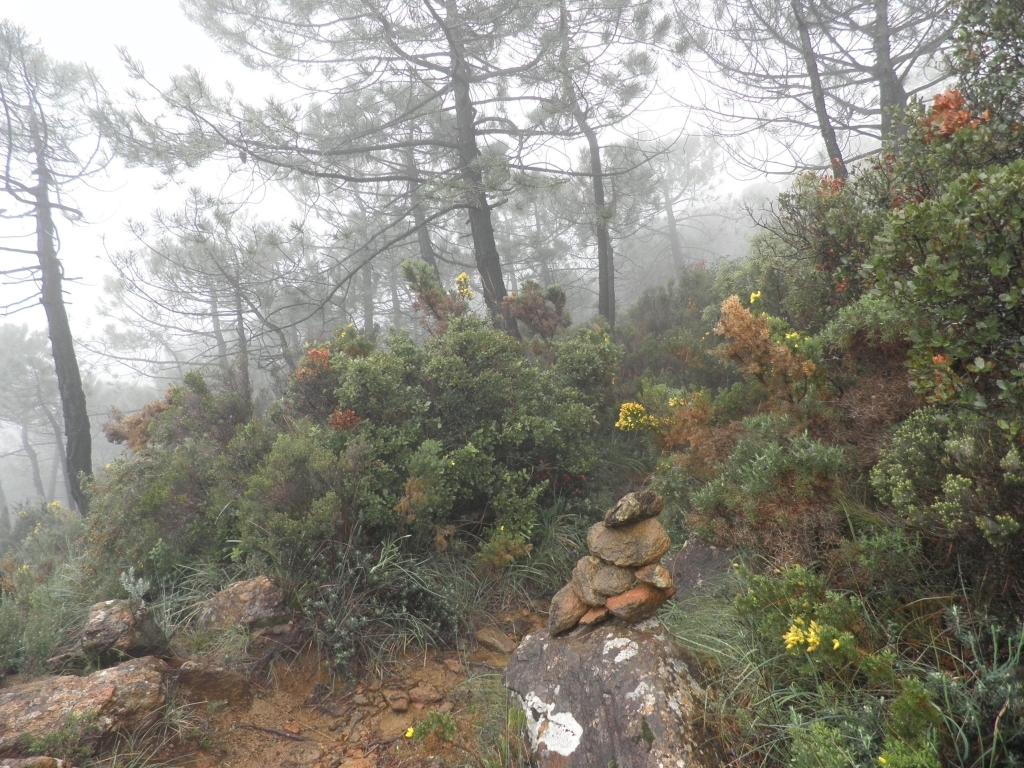What type of natural elements can be seen in the image? There are rocks and plants in the image. What can be seen in the background of the image? There are trees and fog in the background of the image. How many insects can be seen crawling on the rocks in the image? There are no insects visible in the image; it only shows rocks and plants. 